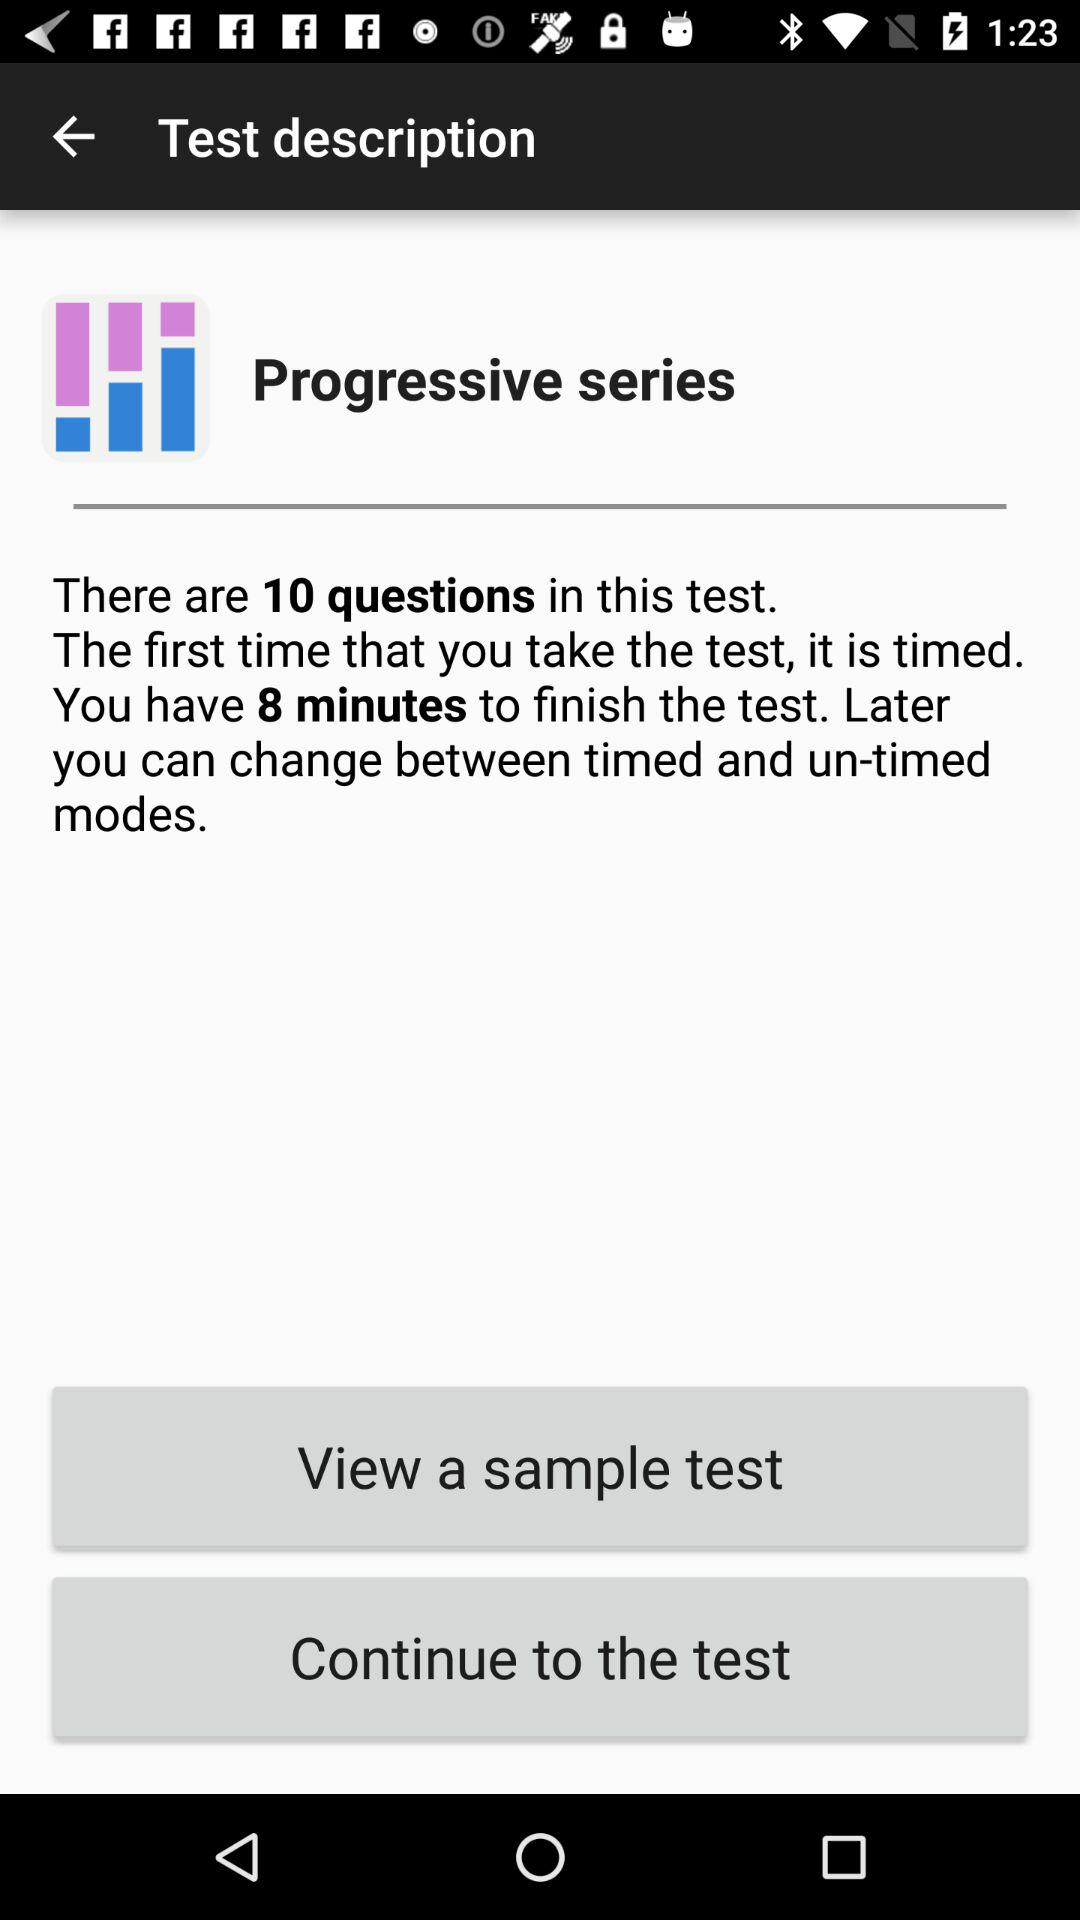How many questions are there in the test? There are 10 questions in the test. 